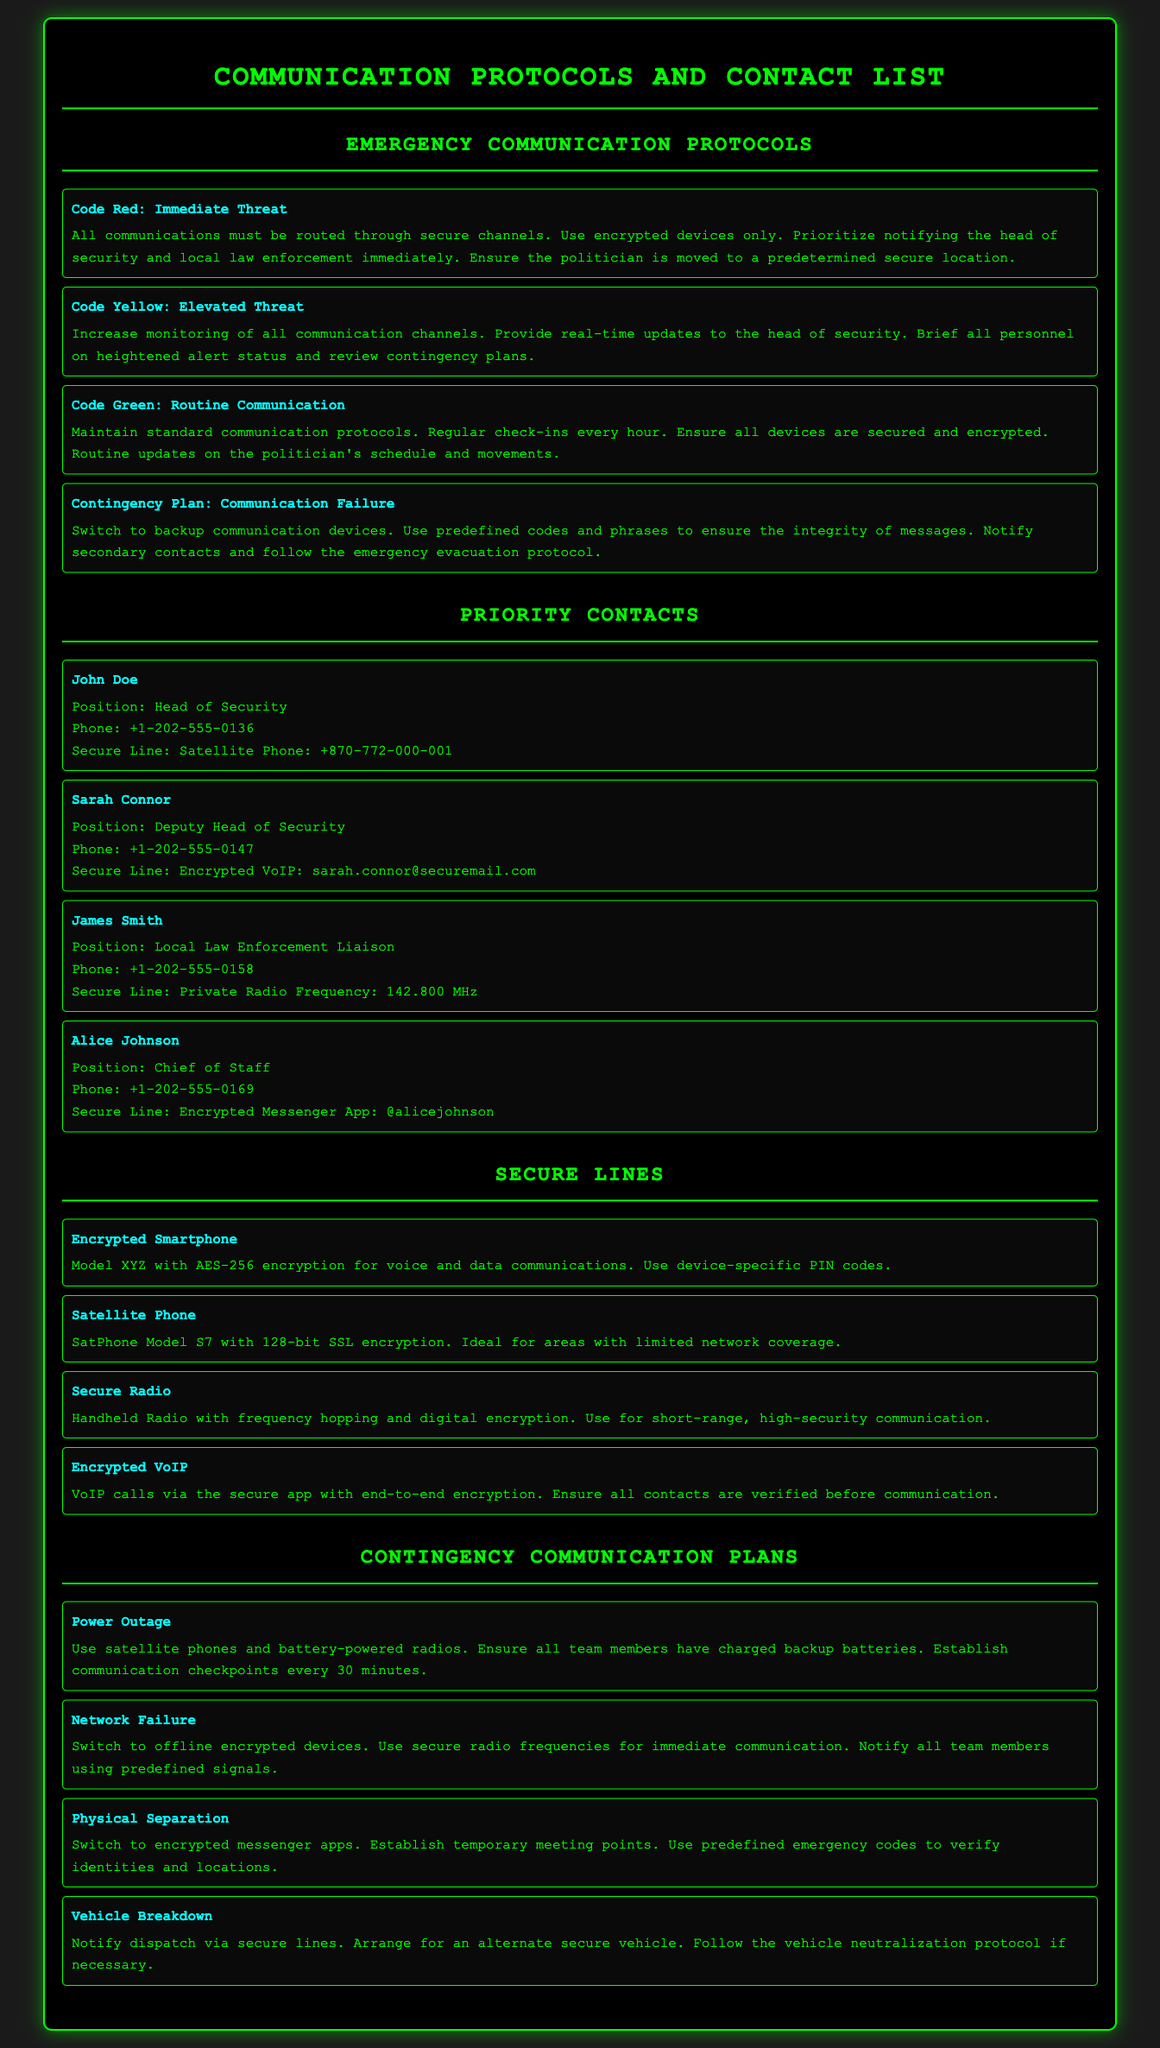what is the secure line for John Doe? John Doe's secure line is a Satellite Phone with the number +870-772-000-001.
Answer: Satellite Phone: +870-772-000-001 what action is required in a Code Red scenario? In a Code Red scenario, communications must be routed through secure channels, and the head of security and local law enforcement must be notified immediately.
Answer: Route communications through secure channels what communication device model is mentioned for handling network failures? The document mentions switching to offline encrypted devices during a network failure.
Answer: Offline encrypted devices what is the frequency for James Smith's secure line? James Smith's secure line operates on a Private Radio Frequency of 142.800 MHz.
Answer: 142.800 MHz how often should regular check-ins occur in a Code Green scenario? Regular check-ins should occur every hour in a Code Green scenario.
Answer: Every hour what is the contingency plan for a power outage? The contingency plan for a power outage includes using satellite phones and battery-powered radios and establishing communication checkpoints every 30 minutes.
Answer: Satellite phones and battery-powered radios who is responsible for providing real-time updates during a Code Yellow? The head of security is responsible for providing real-time updates during a Code Yellow scenario.
Answer: Head of Security what type of security does the Encrypted Smartphone offer? The Encrypted Smartphone offers AES-256 encryption for voice and data communications.
Answer: AES-256 encryption what should team members use in case of physical separation? Team members should switch to encrypted messenger apps in case of physical separation.
Answer: Encrypted messenger apps 